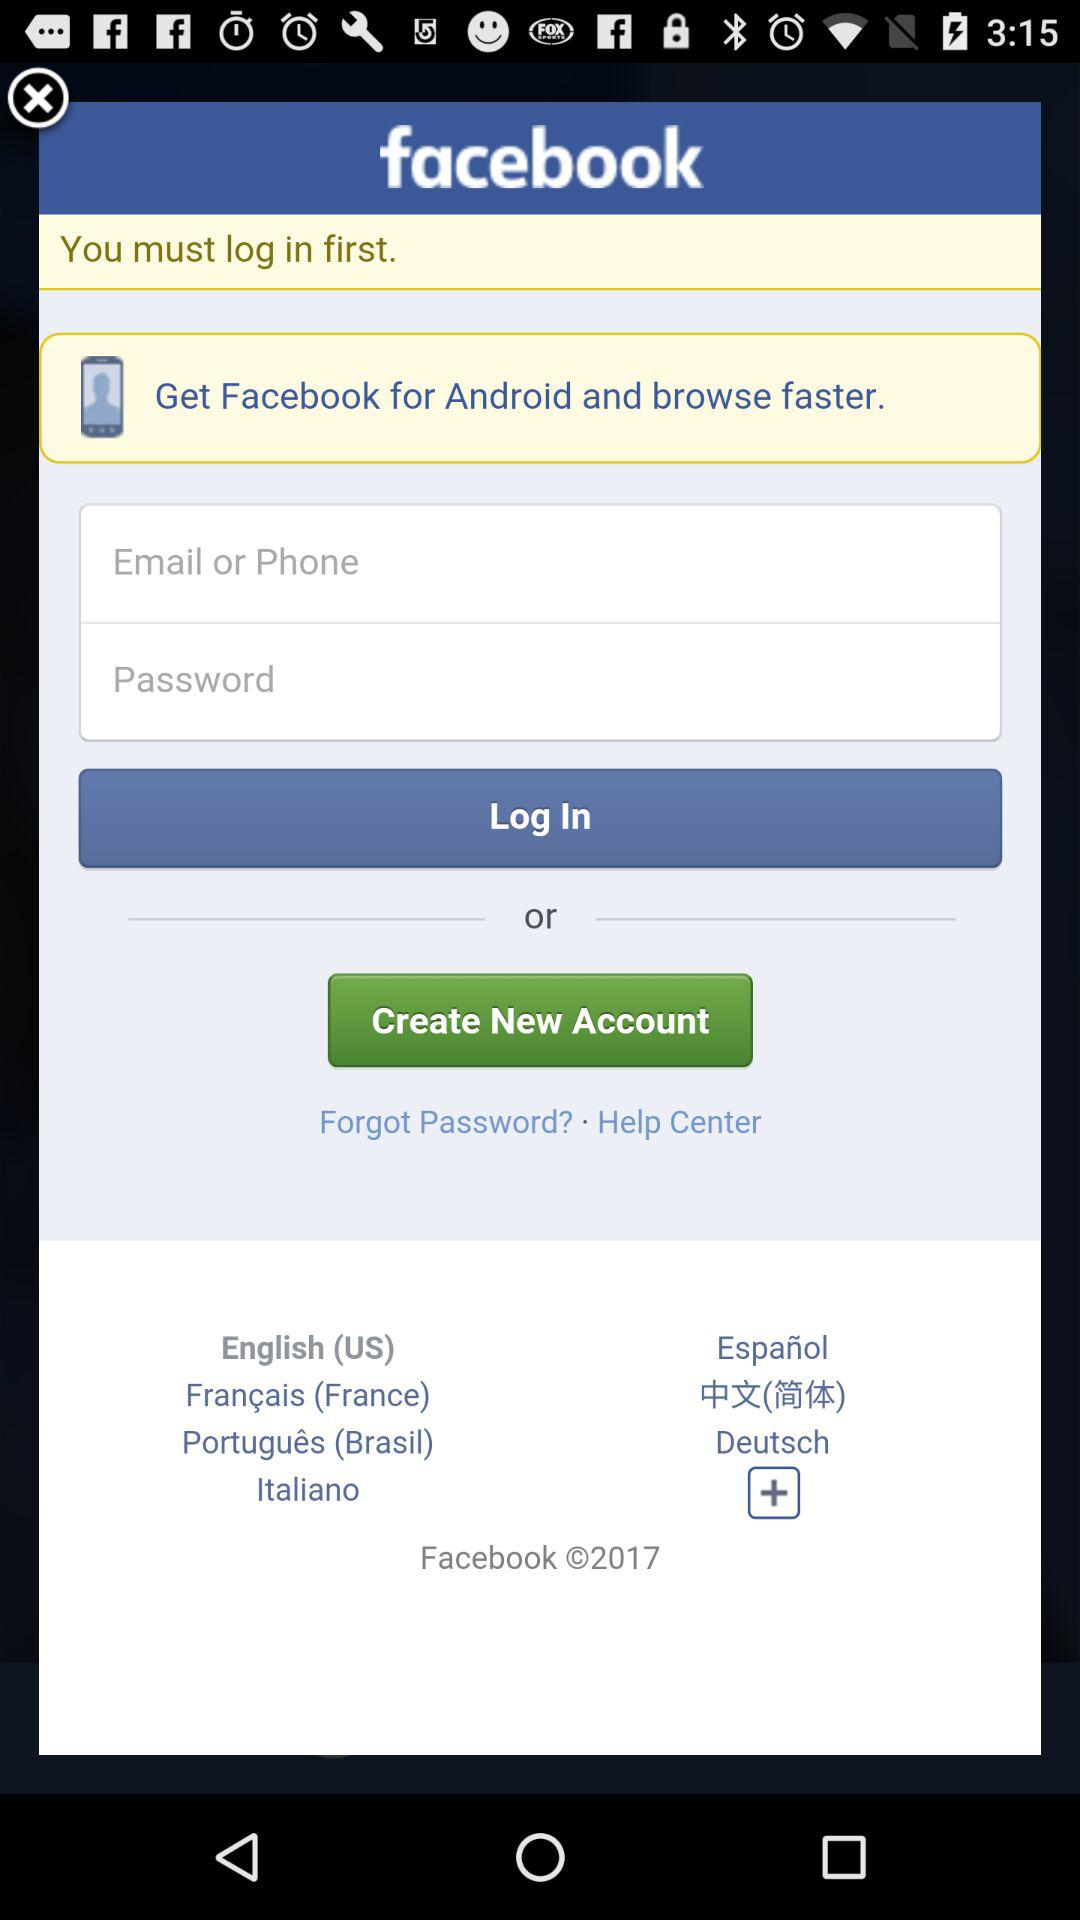What is the name of the application? The name of the application is "facebook". 